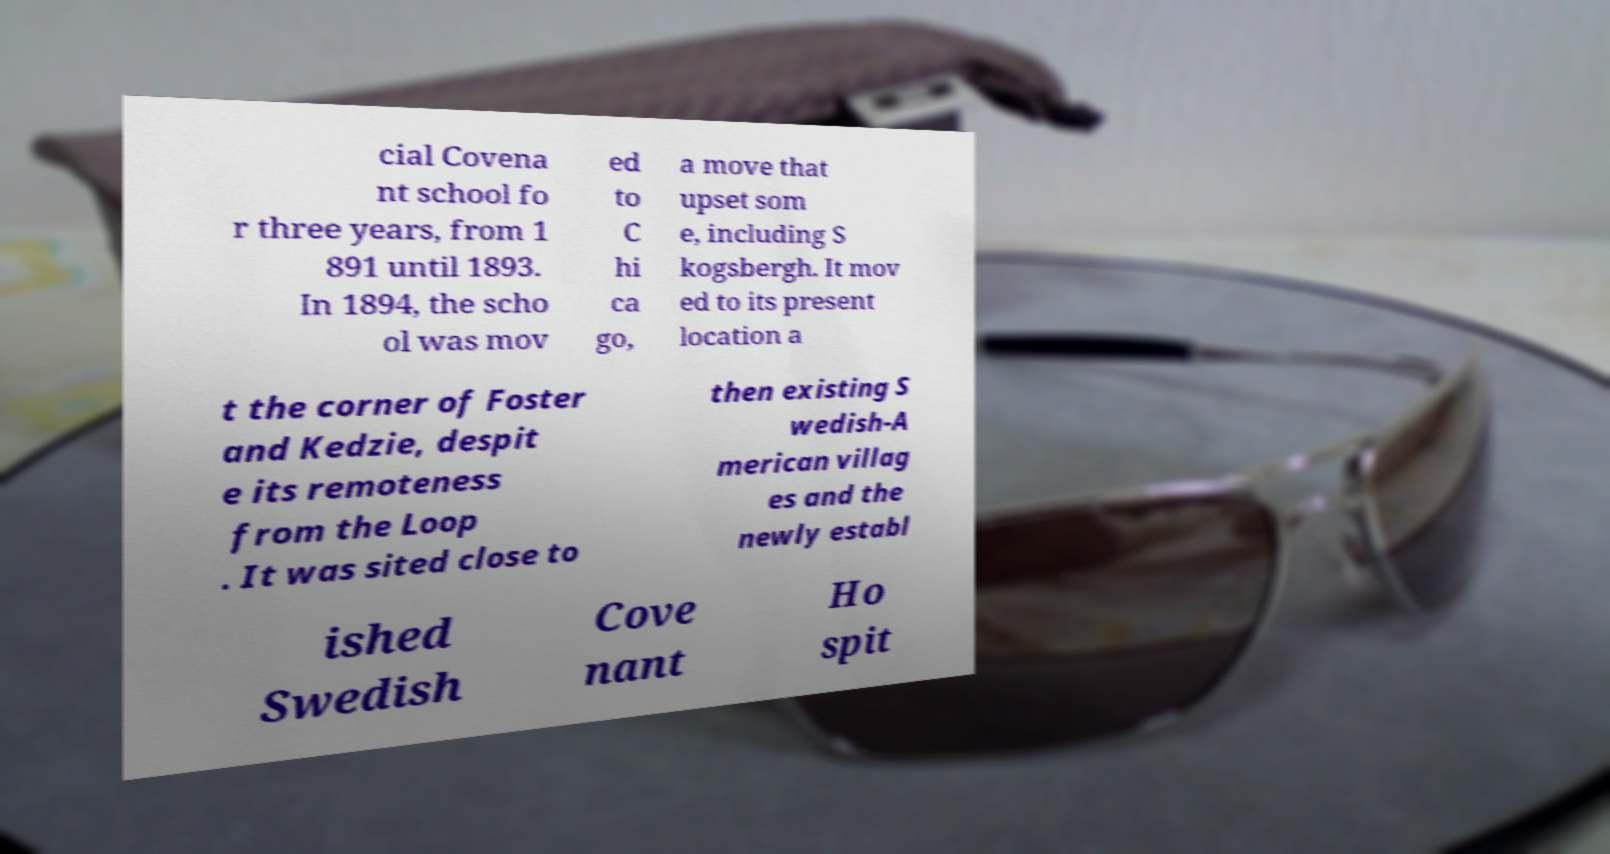Can you read and provide the text displayed in the image?This photo seems to have some interesting text. Can you extract and type it out for me? cial Covena nt school fo r three years, from 1 891 until 1893. In 1894, the scho ol was mov ed to C hi ca go, a move that upset som e, including S kogsbergh. It mov ed to its present location a t the corner of Foster and Kedzie, despit e its remoteness from the Loop . It was sited close to then existing S wedish-A merican villag es and the newly establ ished Swedish Cove nant Ho spit 